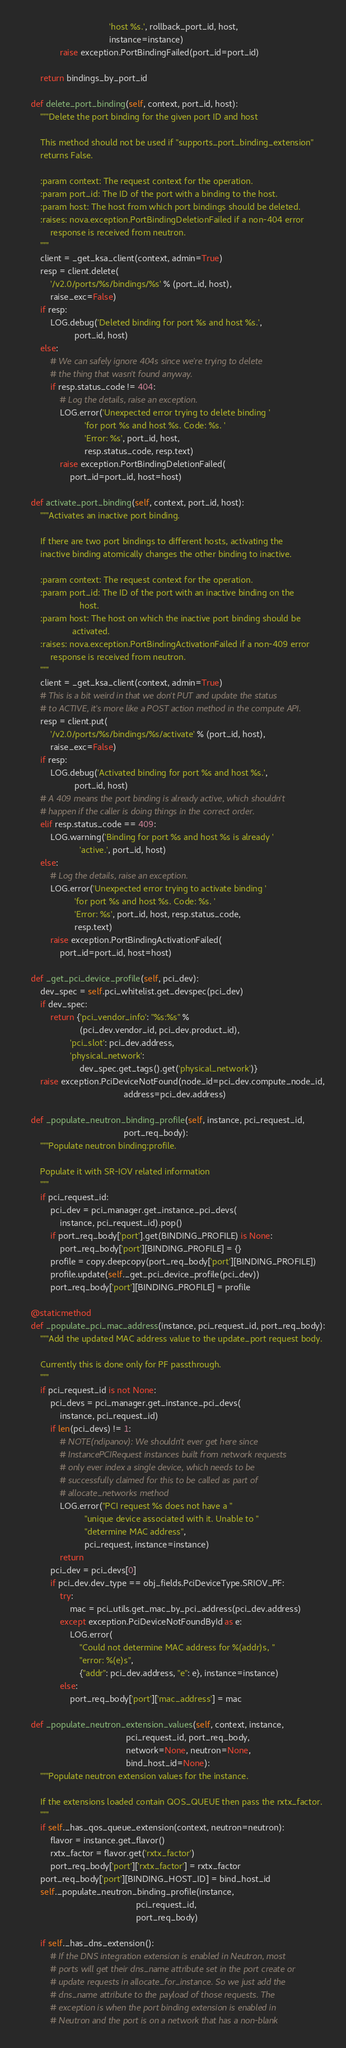<code> <loc_0><loc_0><loc_500><loc_500><_Python_>                                    'host %s.', rollback_port_id, host,
                                    instance=instance)
                raise exception.PortBindingFailed(port_id=port_id)

        return bindings_by_port_id

    def delete_port_binding(self, context, port_id, host):
        """Delete the port binding for the given port ID and host

        This method should not be used if "supports_port_binding_extension"
        returns False.

        :param context: The request context for the operation.
        :param port_id: The ID of the port with a binding to the host.
        :param host: The host from which port bindings should be deleted.
        :raises: nova.exception.PortBindingDeletionFailed if a non-404 error
            response is received from neutron.
        """
        client = _get_ksa_client(context, admin=True)
        resp = client.delete(
            '/v2.0/ports/%s/bindings/%s' % (port_id, host),
            raise_exc=False)
        if resp:
            LOG.debug('Deleted binding for port %s and host %s.',
                      port_id, host)
        else:
            # We can safely ignore 404s since we're trying to delete
            # the thing that wasn't found anyway.
            if resp.status_code != 404:
                # Log the details, raise an exception.
                LOG.error('Unexpected error trying to delete binding '
                          'for port %s and host %s. Code: %s. '
                          'Error: %s', port_id, host,
                          resp.status_code, resp.text)
                raise exception.PortBindingDeletionFailed(
                    port_id=port_id, host=host)

    def activate_port_binding(self, context, port_id, host):
        """Activates an inactive port binding.

        If there are two port bindings to different hosts, activating the
        inactive binding atomically changes the other binding to inactive.

        :param context: The request context for the operation.
        :param port_id: The ID of the port with an inactive binding on the
                        host.
        :param host: The host on which the inactive port binding should be
                     activated.
        :raises: nova.exception.PortBindingActivationFailed if a non-409 error
            response is received from neutron.
        """
        client = _get_ksa_client(context, admin=True)
        # This is a bit weird in that we don't PUT and update the status
        # to ACTIVE, it's more like a POST action method in the compute API.
        resp = client.put(
            '/v2.0/ports/%s/bindings/%s/activate' % (port_id, host),
            raise_exc=False)
        if resp:
            LOG.debug('Activated binding for port %s and host %s.',
                      port_id, host)
        # A 409 means the port binding is already active, which shouldn't
        # happen if the caller is doing things in the correct order.
        elif resp.status_code == 409:
            LOG.warning('Binding for port %s and host %s is already '
                        'active.', port_id, host)
        else:
            # Log the details, raise an exception.
            LOG.error('Unexpected error trying to activate binding '
                      'for port %s and host %s. Code: %s. '
                      'Error: %s', port_id, host, resp.status_code,
                      resp.text)
            raise exception.PortBindingActivationFailed(
                port_id=port_id, host=host)

    def _get_pci_device_profile(self, pci_dev):
        dev_spec = self.pci_whitelist.get_devspec(pci_dev)
        if dev_spec:
            return {'pci_vendor_info': "%s:%s" %
                        (pci_dev.vendor_id, pci_dev.product_id),
                    'pci_slot': pci_dev.address,
                    'physical_network':
                        dev_spec.get_tags().get('physical_network')}
        raise exception.PciDeviceNotFound(node_id=pci_dev.compute_node_id,
                                          address=pci_dev.address)

    def _populate_neutron_binding_profile(self, instance, pci_request_id,
                                          port_req_body):
        """Populate neutron binding:profile.

        Populate it with SR-IOV related information
        """
        if pci_request_id:
            pci_dev = pci_manager.get_instance_pci_devs(
                instance, pci_request_id).pop()
            if port_req_body['port'].get(BINDING_PROFILE) is None:
                port_req_body['port'][BINDING_PROFILE] = {}
            profile = copy.deepcopy(port_req_body['port'][BINDING_PROFILE])
            profile.update(self._get_pci_device_profile(pci_dev))
            port_req_body['port'][BINDING_PROFILE] = profile

    @staticmethod
    def _populate_pci_mac_address(instance, pci_request_id, port_req_body):
        """Add the updated MAC address value to the update_port request body.

        Currently this is done only for PF passthrough.
        """
        if pci_request_id is not None:
            pci_devs = pci_manager.get_instance_pci_devs(
                instance, pci_request_id)
            if len(pci_devs) != 1:
                # NOTE(ndipanov): We shouldn't ever get here since
                # InstancePCIRequest instances built from network requests
                # only ever index a single device, which needs to be
                # successfully claimed for this to be called as part of
                # allocate_networks method
                LOG.error("PCI request %s does not have a "
                          "unique device associated with it. Unable to "
                          "determine MAC address",
                          pci_request, instance=instance)
                return
            pci_dev = pci_devs[0]
            if pci_dev.dev_type == obj_fields.PciDeviceType.SRIOV_PF:
                try:
                    mac = pci_utils.get_mac_by_pci_address(pci_dev.address)
                except exception.PciDeviceNotFoundById as e:
                    LOG.error(
                        "Could not determine MAC address for %(addr)s, "
                        "error: %(e)s",
                        {"addr": pci_dev.address, "e": e}, instance=instance)
                else:
                    port_req_body['port']['mac_address'] = mac

    def _populate_neutron_extension_values(self, context, instance,
                                           pci_request_id, port_req_body,
                                           network=None, neutron=None,
                                           bind_host_id=None):
        """Populate neutron extension values for the instance.

        If the extensions loaded contain QOS_QUEUE then pass the rxtx_factor.
        """
        if self._has_qos_queue_extension(context, neutron=neutron):
            flavor = instance.get_flavor()
            rxtx_factor = flavor.get('rxtx_factor')
            port_req_body['port']['rxtx_factor'] = rxtx_factor
        port_req_body['port'][BINDING_HOST_ID] = bind_host_id
        self._populate_neutron_binding_profile(instance,
                                               pci_request_id,
                                               port_req_body)

        if self._has_dns_extension():
            # If the DNS integration extension is enabled in Neutron, most
            # ports will get their dns_name attribute set in the port create or
            # update requests in allocate_for_instance. So we just add the
            # dns_name attribute to the payload of those requests. The
            # exception is when the port binding extension is enabled in
            # Neutron and the port is on a network that has a non-blank</code> 